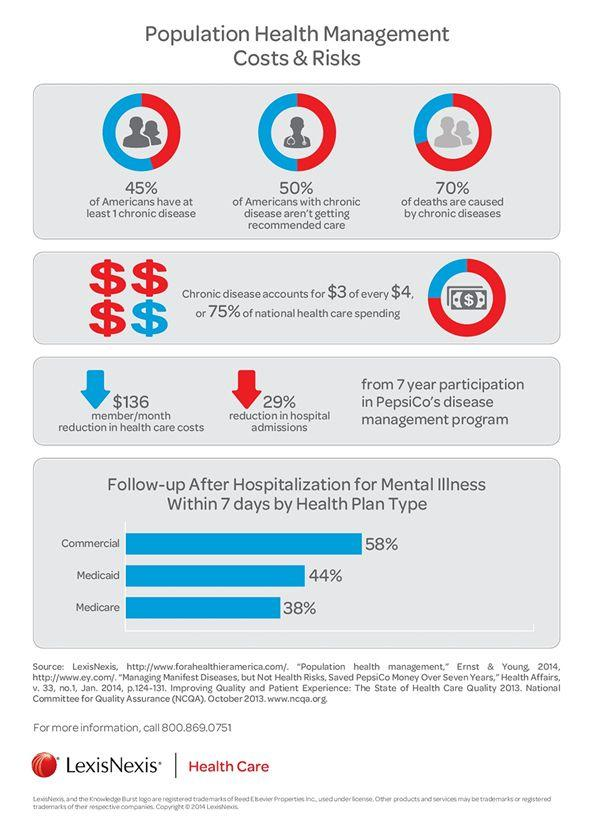Mention a couple of crucial points in this snapshot. Approximately 25% of the money spent on health care in the United States is not dedicated to national health care. According to recent data, approximately 30% of all deaths are not caused by chronic diseases. According to recent statistics, approximately 45% of Americans are afflicted with at least one chronic disease. 